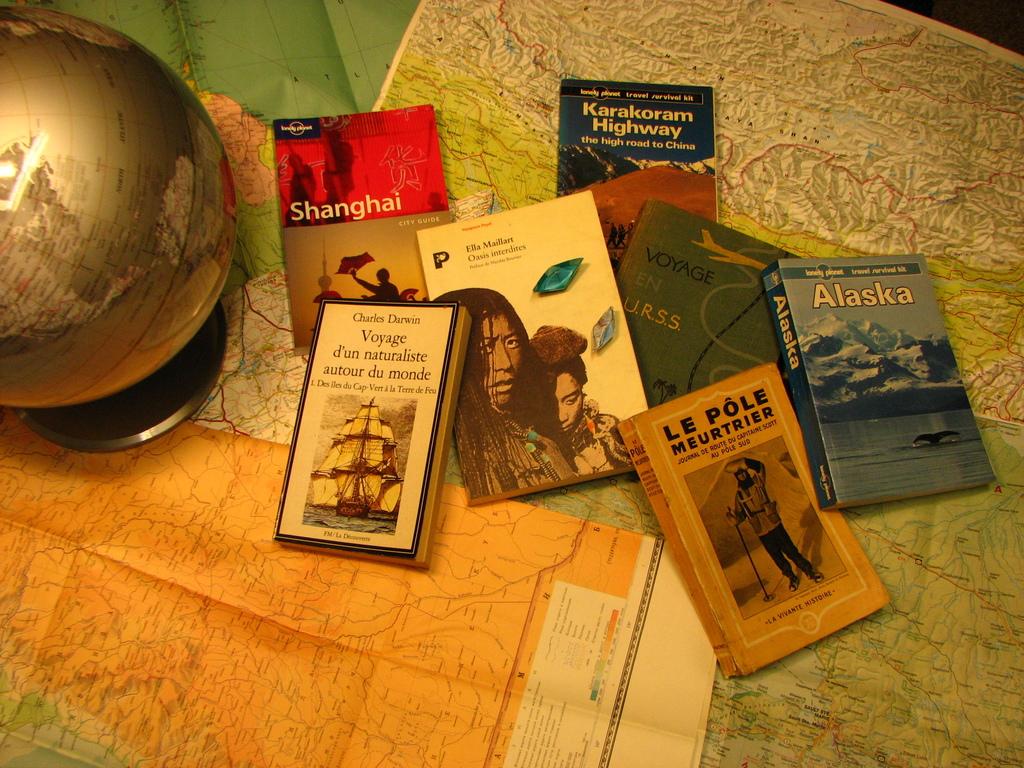What is the title of the orange book?
Make the answer very short. Le pole meurtrier. 